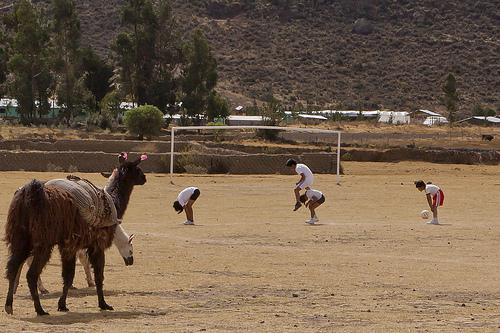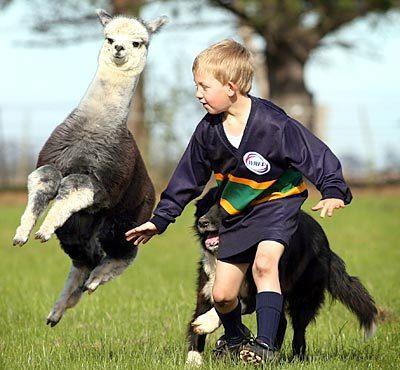The first image is the image on the left, the second image is the image on the right. Assess this claim about the two images: "In one of the images, there is a soccer ball between a person and a llama.". Correct or not? Answer yes or no. No. The first image is the image on the left, the second image is the image on the right. For the images displayed, is the sentence "One image shows a person in blue pants standing to the left of a brown llama, with a soccer ball on the ground between them." factually correct? Answer yes or no. No. 